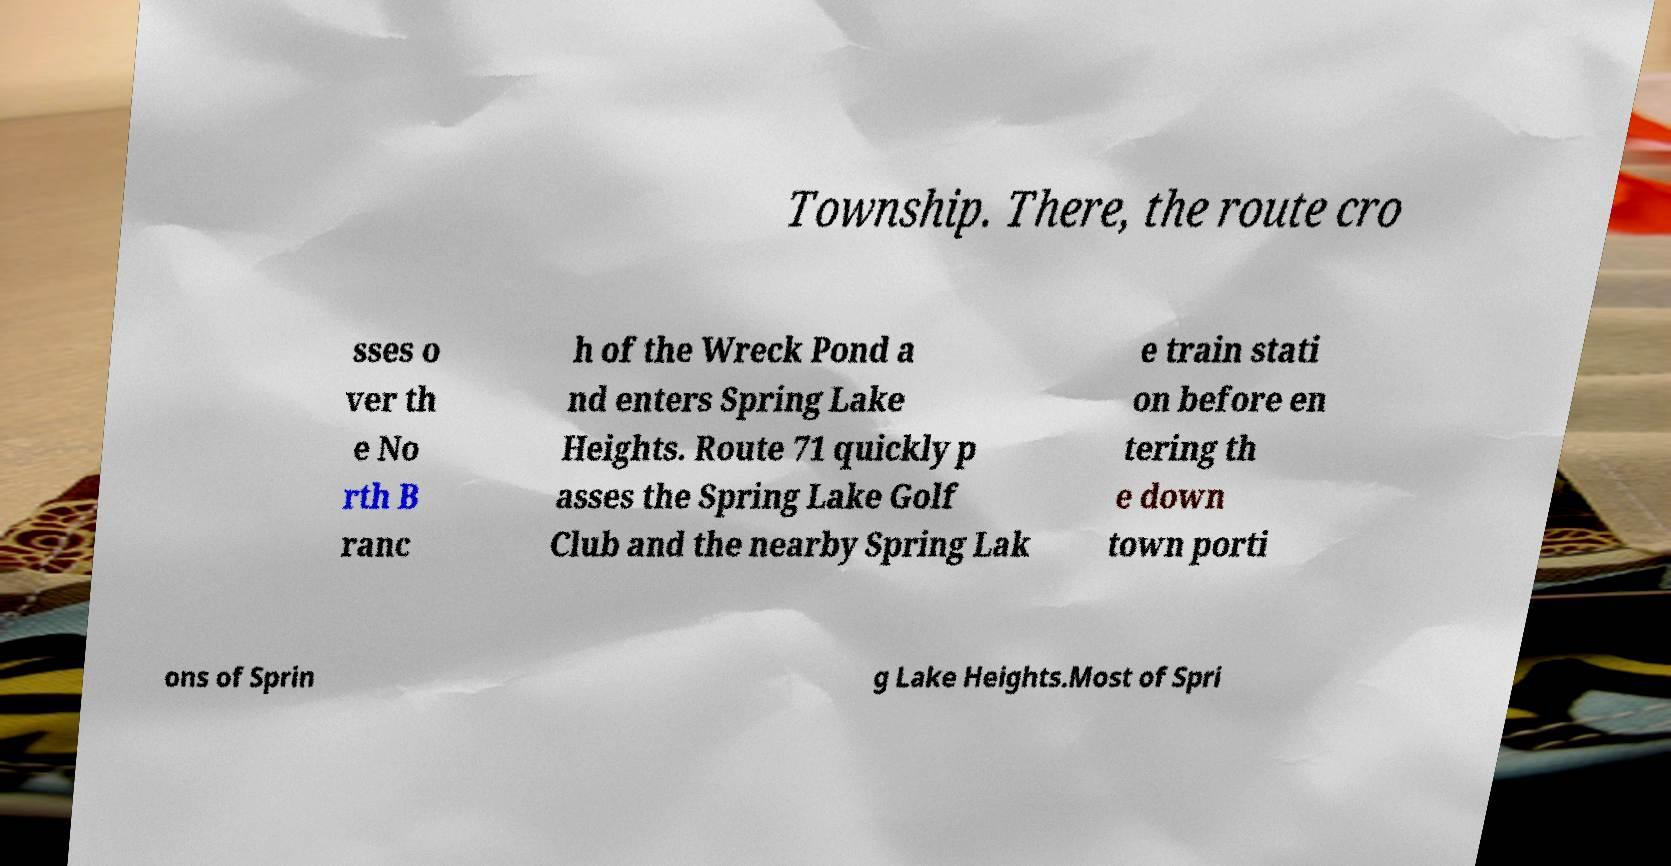Can you read and provide the text displayed in the image?This photo seems to have some interesting text. Can you extract and type it out for me? Township. There, the route cro sses o ver th e No rth B ranc h of the Wreck Pond a nd enters Spring Lake Heights. Route 71 quickly p asses the Spring Lake Golf Club and the nearby Spring Lak e train stati on before en tering th e down town porti ons of Sprin g Lake Heights.Most of Spri 